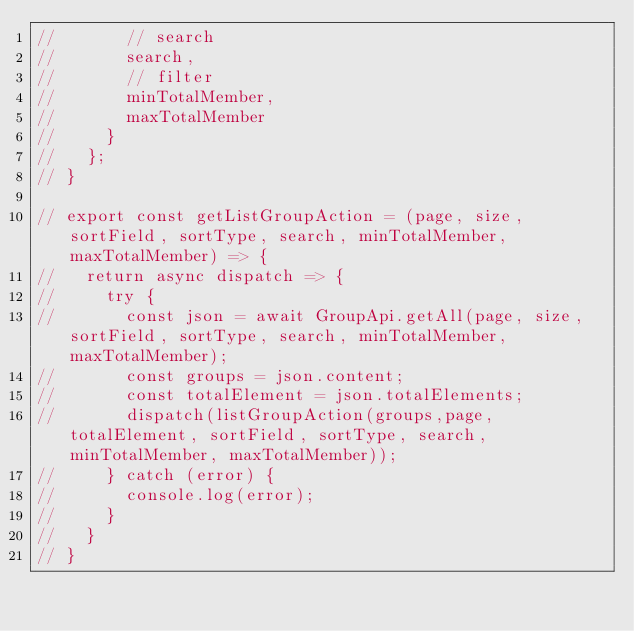Convert code to text. <code><loc_0><loc_0><loc_500><loc_500><_JavaScript_>//       // search
//       search,
//       // filter
//       minTotalMember,
//       maxTotalMember
//     }
//   };
// }

// export const getListGroupAction = (page, size, sortField, sortType, search, minTotalMember, maxTotalMember) => {
//   return async dispatch => {
//     try {
//       const json = await GroupApi.getAll(page, size, sortField, sortType, search, minTotalMember, maxTotalMember);
//       const groups = json.content;
//       const totalElement = json.totalElements;
//       dispatch(listGroupAction(groups,page, totalElement, sortField, sortType, search, minTotalMember, maxTotalMember));
//     } catch (error) {
//       console.log(error);
//     }
//   }
// }</code> 